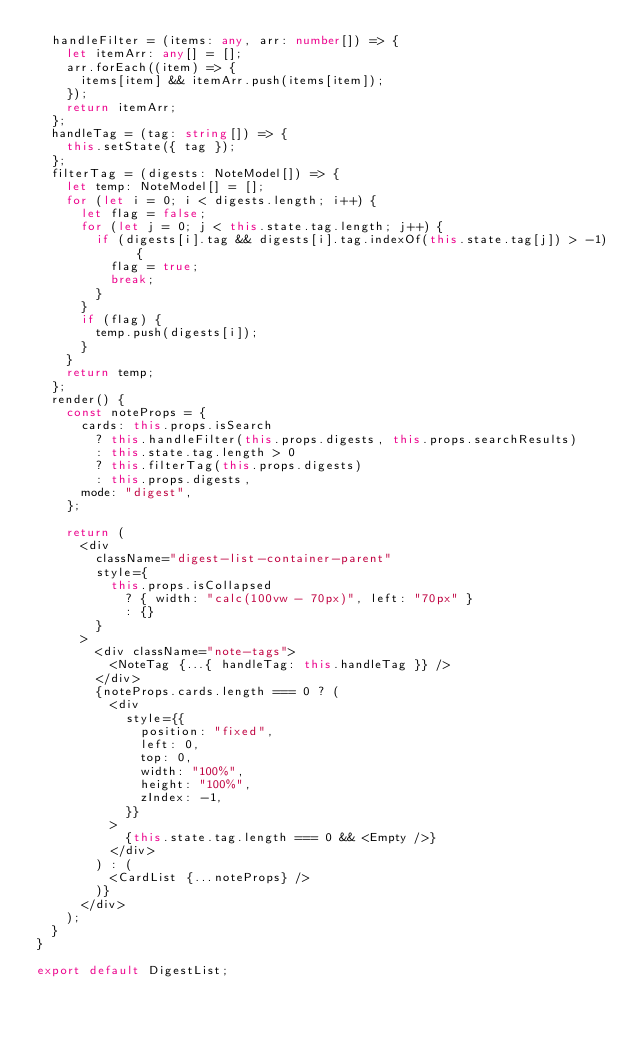Convert code to text. <code><loc_0><loc_0><loc_500><loc_500><_TypeScript_>  handleFilter = (items: any, arr: number[]) => {
    let itemArr: any[] = [];
    arr.forEach((item) => {
      items[item] && itemArr.push(items[item]);
    });
    return itemArr;
  };
  handleTag = (tag: string[]) => {
    this.setState({ tag });
  };
  filterTag = (digests: NoteModel[]) => {
    let temp: NoteModel[] = [];
    for (let i = 0; i < digests.length; i++) {
      let flag = false;
      for (let j = 0; j < this.state.tag.length; j++) {
        if (digests[i].tag && digests[i].tag.indexOf(this.state.tag[j]) > -1) {
          flag = true;
          break;
        }
      }
      if (flag) {
        temp.push(digests[i]);
      }
    }
    return temp;
  };
  render() {
    const noteProps = {
      cards: this.props.isSearch
        ? this.handleFilter(this.props.digests, this.props.searchResults)
        : this.state.tag.length > 0
        ? this.filterTag(this.props.digests)
        : this.props.digests,
      mode: "digest",
    };

    return (
      <div
        className="digest-list-container-parent"
        style={
          this.props.isCollapsed
            ? { width: "calc(100vw - 70px)", left: "70px" }
            : {}
        }
      >
        <div className="note-tags">
          <NoteTag {...{ handleTag: this.handleTag }} />
        </div>
        {noteProps.cards.length === 0 ? (
          <div
            style={{
              position: "fixed",
              left: 0,
              top: 0,
              width: "100%",
              height: "100%",
              zIndex: -1,
            }}
          >
            {this.state.tag.length === 0 && <Empty />}
          </div>
        ) : (
          <CardList {...noteProps} />
        )}
      </div>
    );
  }
}

export default DigestList;
</code> 